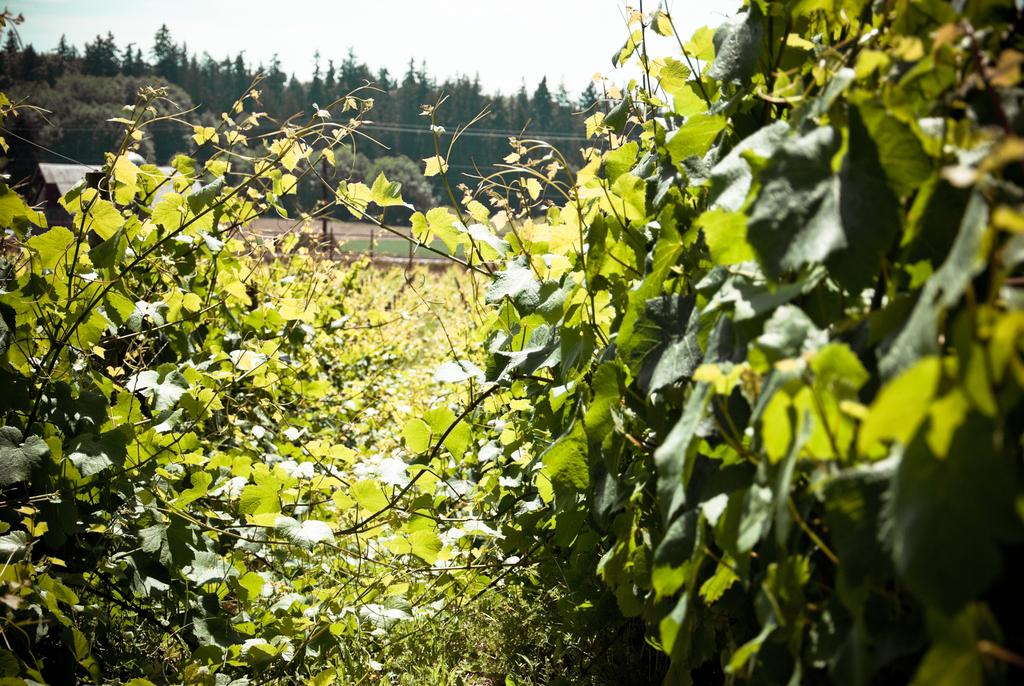What type of vegetation can be seen in the image? There are trees, plants, and grass visible in the image. What part of the natural environment is visible in the image? The sky is visible in the image. What month is it in the image? The month cannot be determined from the image, as there is no information about the time of year. Is there a ship visible in the image? No, there is no ship present in the image. 